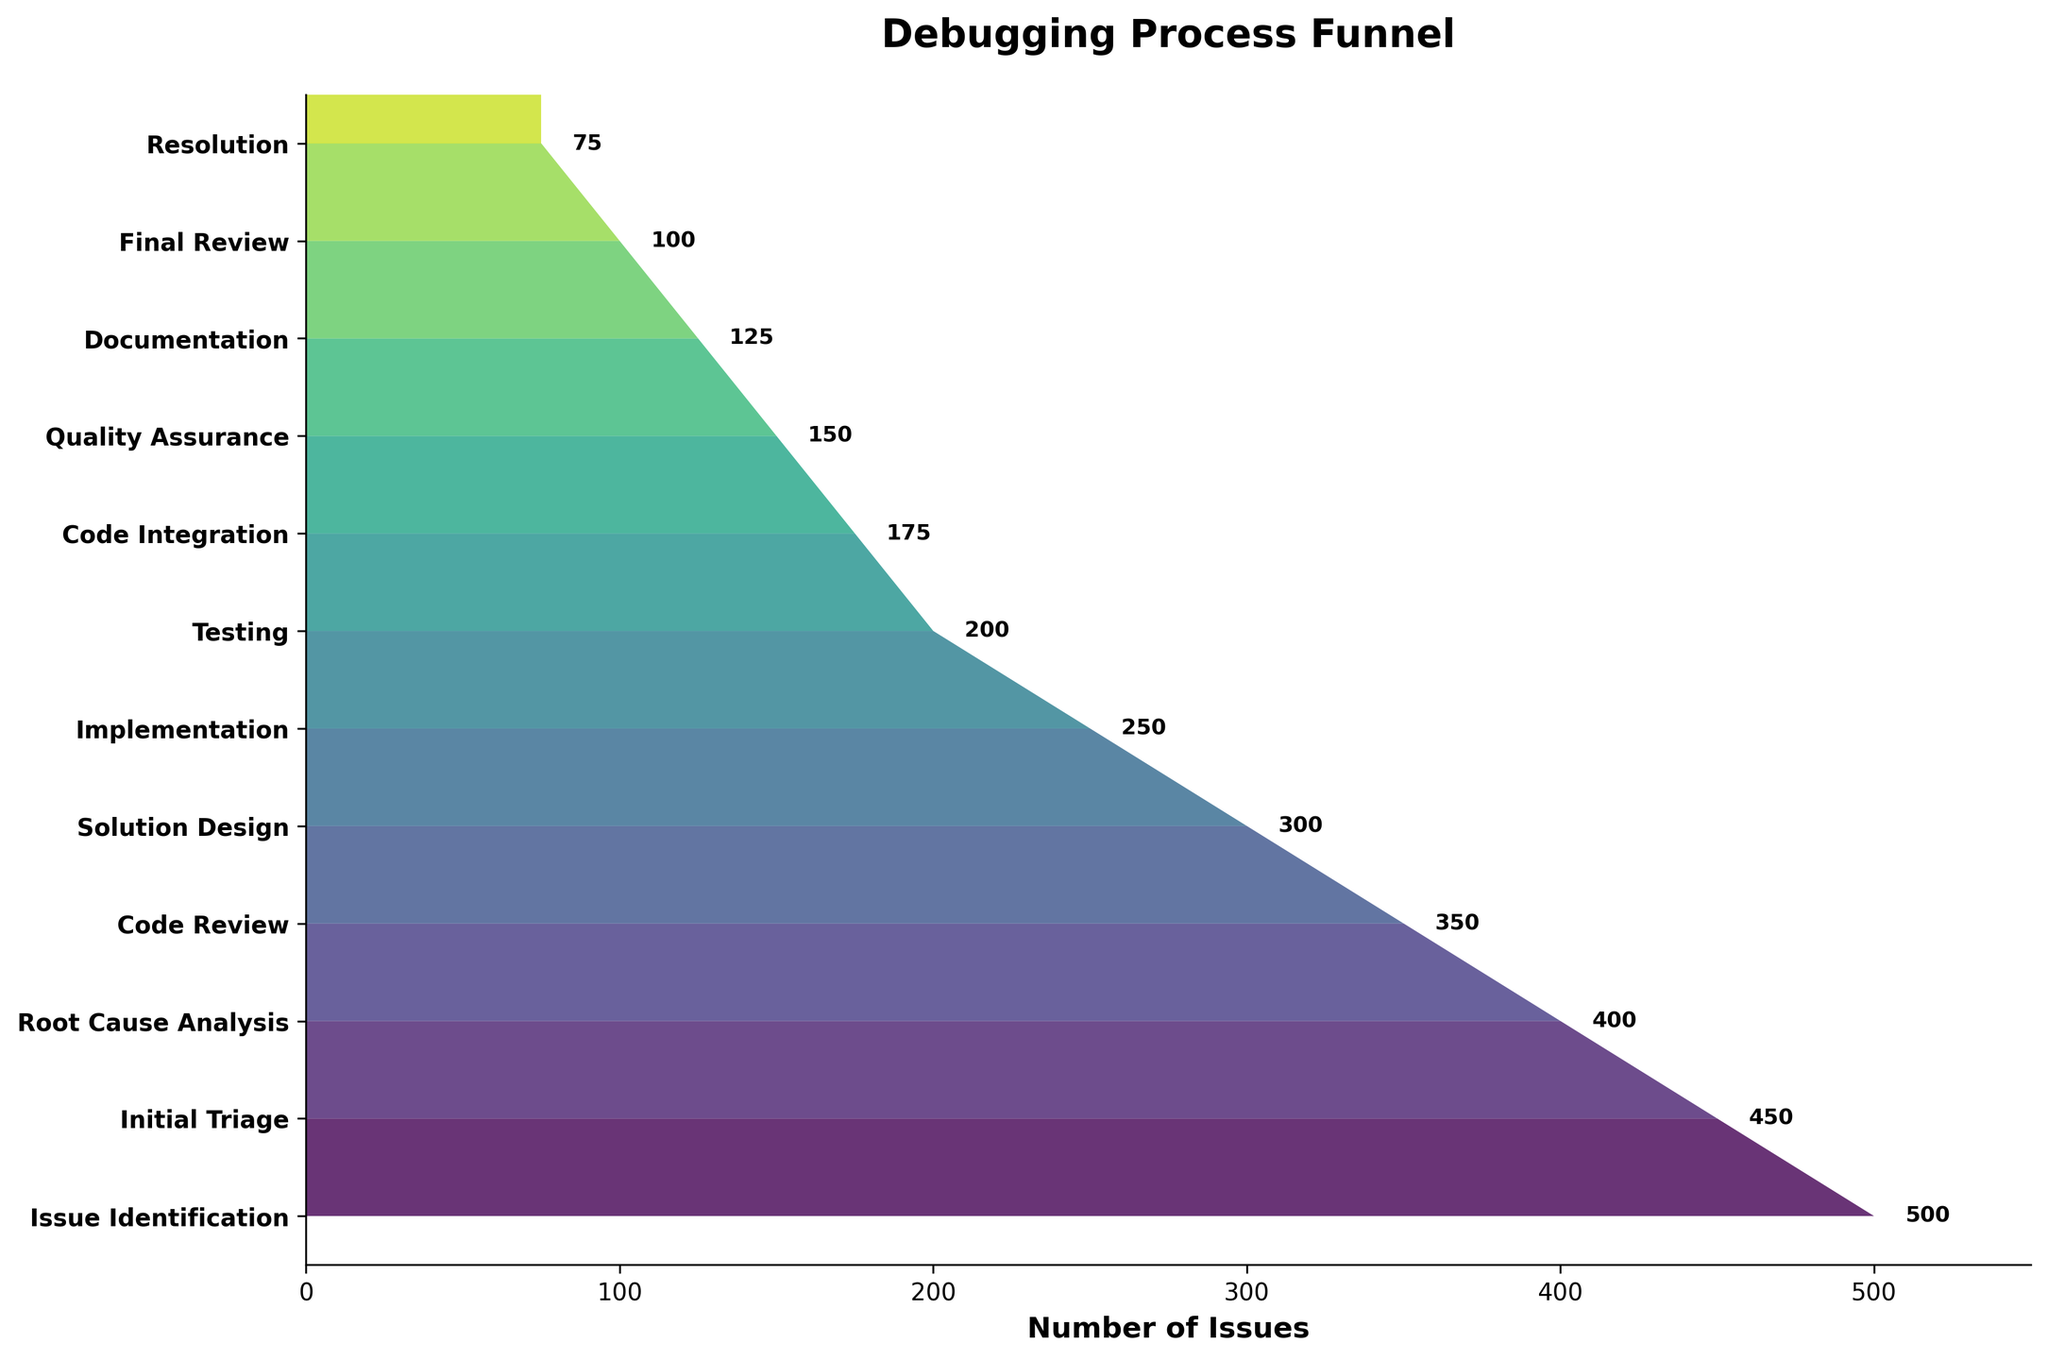what is the title of the plot? The title is usually placed at the top center of the plot, and in this plot, the prominent bold text reads 'Debugging Process Funnel'.
Answer: Debugging Process Funnel what is the y-axis label for the highest number of issues? The highest number of issues is located at the topmost position of the funnel chart. The stage associated with it is 'Issue Identification'.
Answer: Issue Identification how many stages are depicted in the funnel chart? Count the distinct labels along the y-axis, representing each debugging process stage. There are 12 stages in total.
Answer: 12 what is the difference in the number of issues between 'Code Review' and 'Solution Design'? 'Code Review' has 350 issues and 'Solution Design' has 300 issues. Subtracting these gives 350 - 300 = 50.
Answer: 50 which stage comes immediately before 'Resolution'? Trace the funnel chart from bottom to top to find the stage label right before 'Resolution'. 'Final Review' is the stage immediately before 'Resolution'.
Answer: Final Review which stage has exactly half the number of issues as the 'Initial Triage'? 'Initial Triage' has 450 issues. Half of this number is 450 / 2 = 225. The stage 'Testing' has 200 issues, which is the closest available stage with a similar value. None of the stages has exactly 225 issues but 'Testing' is close.
Answer: None exactly, closest is Testing how many stages have fewer than 200 issues? Identify stages by scrutinizing their issue numbers and count those below 200: 'Code Integration' (175), 'Quality Assurance' (150), 'Documentation' (125), 'Final Review' (100), and 'Resolution' (75). There are 5 stages in total.
Answer: 5 what percentage of the issues is resolved after the 'Solution Design' stage? 'Solution Design' starts with 300 issues, and 'Resolution' ends with 75 issues. The resolved issues are 300 - 75 = 225. To find the percentage: (225 / 300) * 100 = 75%.
Answer: 75% which stage reduces the number of issues by the smallest amount? Evaluate the differences between consecutive stages and find the smallest reduction: 'Implementation' to 'Testing' = 250 - 200 = 50 issues. This is the smallest reduction.
Answer: Implementation to Testing (50 issues) what is the average number of issues across all stages? Sum the number of issues across all stages: 500 + 450 + 400 + 350 + 300 + 250 + 200 + 175 + 150 + 125 + 100 + 75 = 3075. Divide by the total number of stages (12) to find the average: 3075 / 12 = 256.25.
Answer: 256.25 